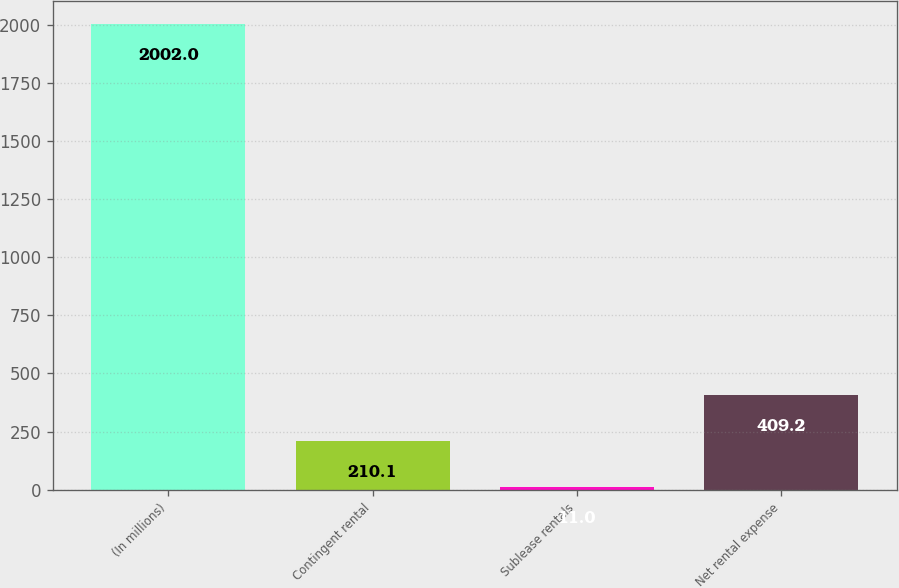<chart> <loc_0><loc_0><loc_500><loc_500><bar_chart><fcel>(In millions)<fcel>Contingent rental<fcel>Sublease rentals<fcel>Net rental expense<nl><fcel>2002<fcel>210.1<fcel>11<fcel>409.2<nl></chart> 